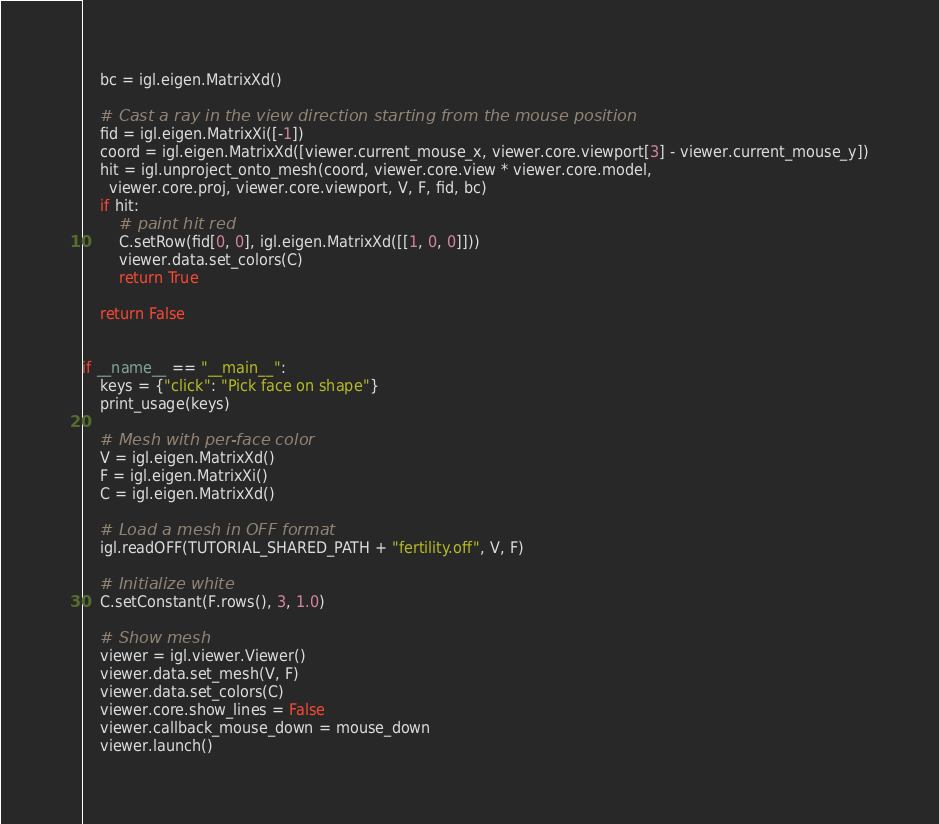<code> <loc_0><loc_0><loc_500><loc_500><_Python_>    bc = igl.eigen.MatrixXd()

    # Cast a ray in the view direction starting from the mouse position
    fid = igl.eigen.MatrixXi([-1])
    coord = igl.eigen.MatrixXd([viewer.current_mouse_x, viewer.core.viewport[3] - viewer.current_mouse_y])
    hit = igl.unproject_onto_mesh(coord, viewer.core.view * viewer.core.model,
      viewer.core.proj, viewer.core.viewport, V, F, fid, bc)
    if hit:
        # paint hit red
        C.setRow(fid[0, 0], igl.eigen.MatrixXd([[1, 0, 0]]))
        viewer.data.set_colors(C)
        return True

    return False


if __name__ == "__main__":
    keys = {"click": "Pick face on shape"}
    print_usage(keys)

    # Mesh with per-face color
    V = igl.eigen.MatrixXd()
    F = igl.eigen.MatrixXi()
    C = igl.eigen.MatrixXd()

    # Load a mesh in OFF format
    igl.readOFF(TUTORIAL_SHARED_PATH + "fertility.off", V, F)

    # Initialize white
    C.setConstant(F.rows(), 3, 1.0)

    # Show mesh
    viewer = igl.viewer.Viewer()
    viewer.data.set_mesh(V, F)
    viewer.data.set_colors(C)
    viewer.core.show_lines = False
    viewer.callback_mouse_down = mouse_down
    viewer.launch()
</code> 